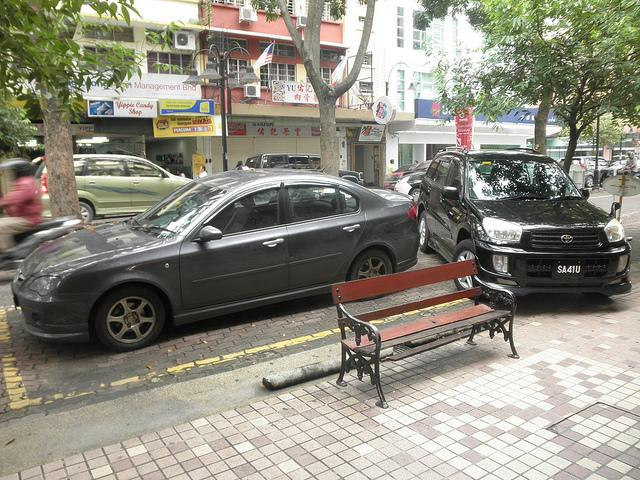Which car violates the law? black car 